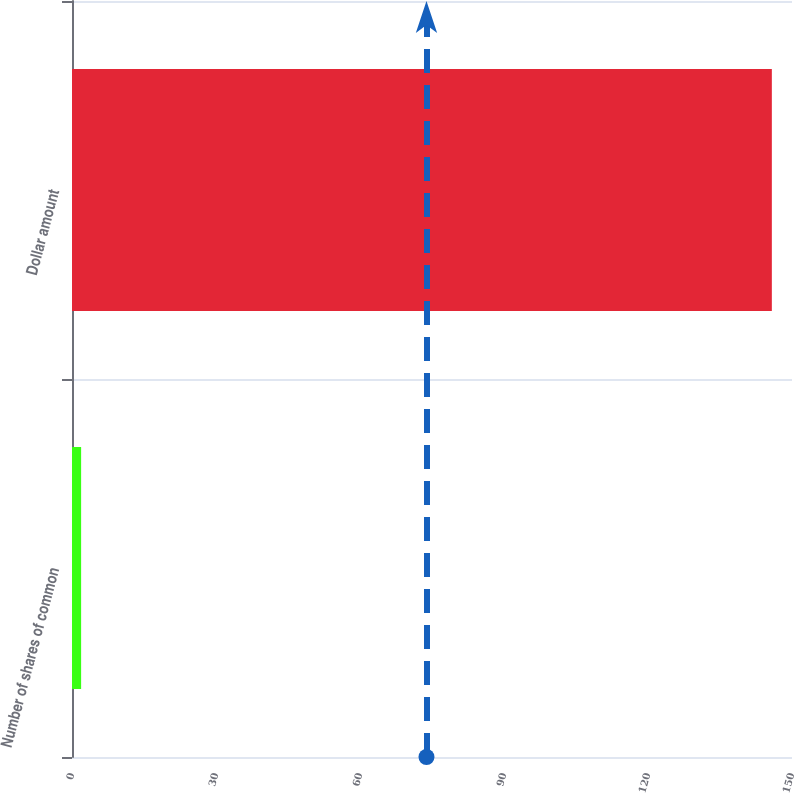Convert chart to OTSL. <chart><loc_0><loc_0><loc_500><loc_500><bar_chart><fcel>Number of shares of common<fcel>Dollar amount<nl><fcel>1.9<fcel>145.8<nl></chart> 